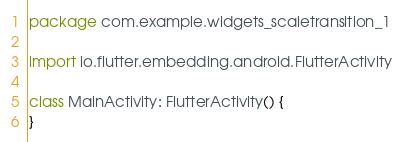Convert code to text. <code><loc_0><loc_0><loc_500><loc_500><_Kotlin_>package com.example.widgets_scaletransition_1

import io.flutter.embedding.android.FlutterActivity

class MainActivity: FlutterActivity() {
}
</code> 